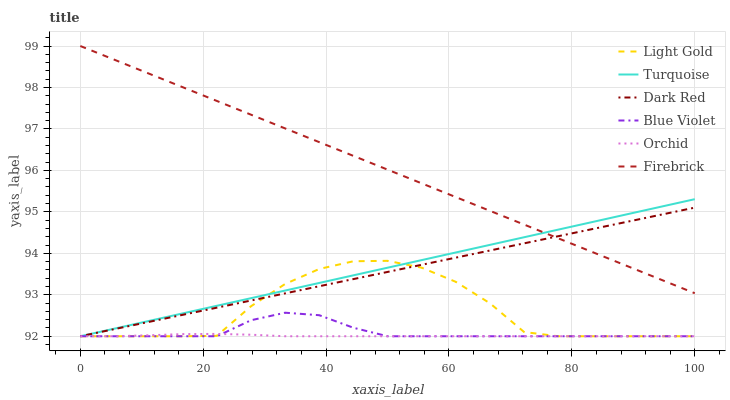Does Dark Red have the minimum area under the curve?
Answer yes or no. No. Does Dark Red have the maximum area under the curve?
Answer yes or no. No. Is Firebrick the smoothest?
Answer yes or no. No. Is Firebrick the roughest?
Answer yes or no. No. Does Firebrick have the lowest value?
Answer yes or no. No. Does Dark Red have the highest value?
Answer yes or no. No. Is Light Gold less than Firebrick?
Answer yes or no. Yes. Is Firebrick greater than Orchid?
Answer yes or no. Yes. Does Light Gold intersect Firebrick?
Answer yes or no. No. 